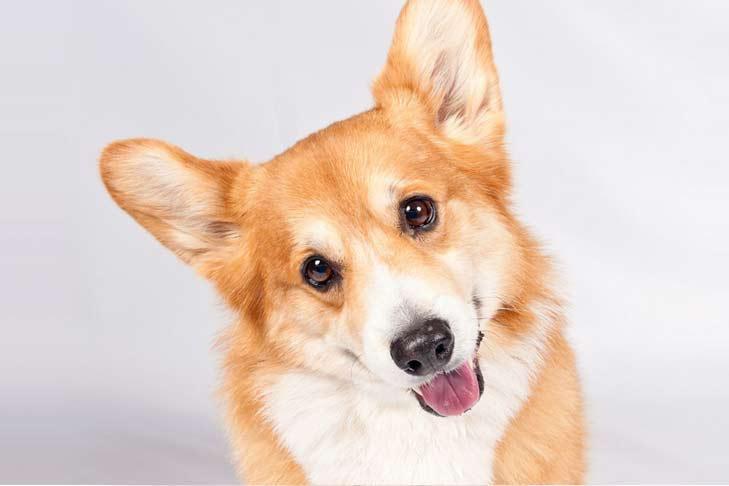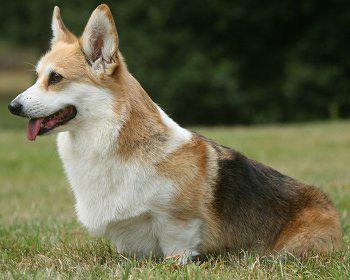The first image is the image on the left, the second image is the image on the right. Examine the images to the left and right. Is the description "The dog standing in the grass is in full profile looking toward the camera." accurate? Answer yes or no. No. 